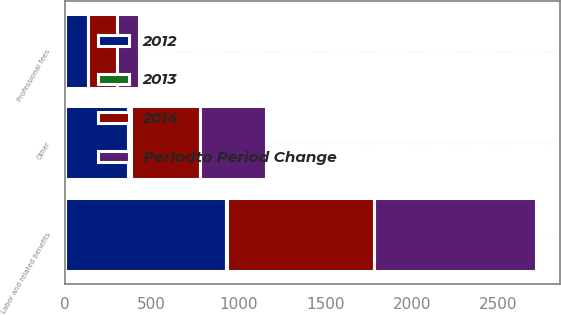<chart> <loc_0><loc_0><loc_500><loc_500><stacked_bar_chart><ecel><fcel>Labor and related benefits<fcel>Professional fees<fcel>Other<nl><fcel>Periodto Period Change<fcel>933<fcel>126<fcel>381<nl><fcel>2013<fcel>2<fcel>5<fcel>16<nl><fcel>2012<fcel>931<fcel>131<fcel>365<nl><fcel>2014<fcel>850<fcel>163<fcel>399<nl></chart> 